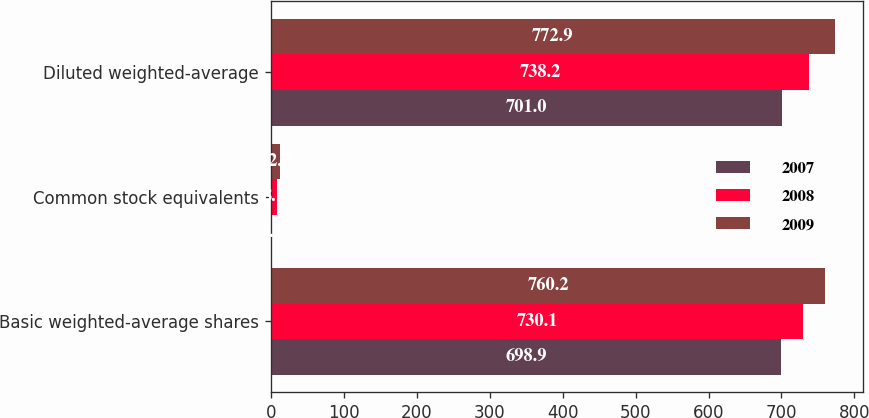Convert chart to OTSL. <chart><loc_0><loc_0><loc_500><loc_500><stacked_bar_chart><ecel><fcel>Basic weighted-average shares<fcel>Common stock equivalents<fcel>Diluted weighted-average<nl><fcel>2007<fcel>698.9<fcel>2.1<fcel>701<nl><fcel>2008<fcel>730.1<fcel>8.1<fcel>738.2<nl><fcel>2009<fcel>760.2<fcel>12.7<fcel>772.9<nl></chart> 